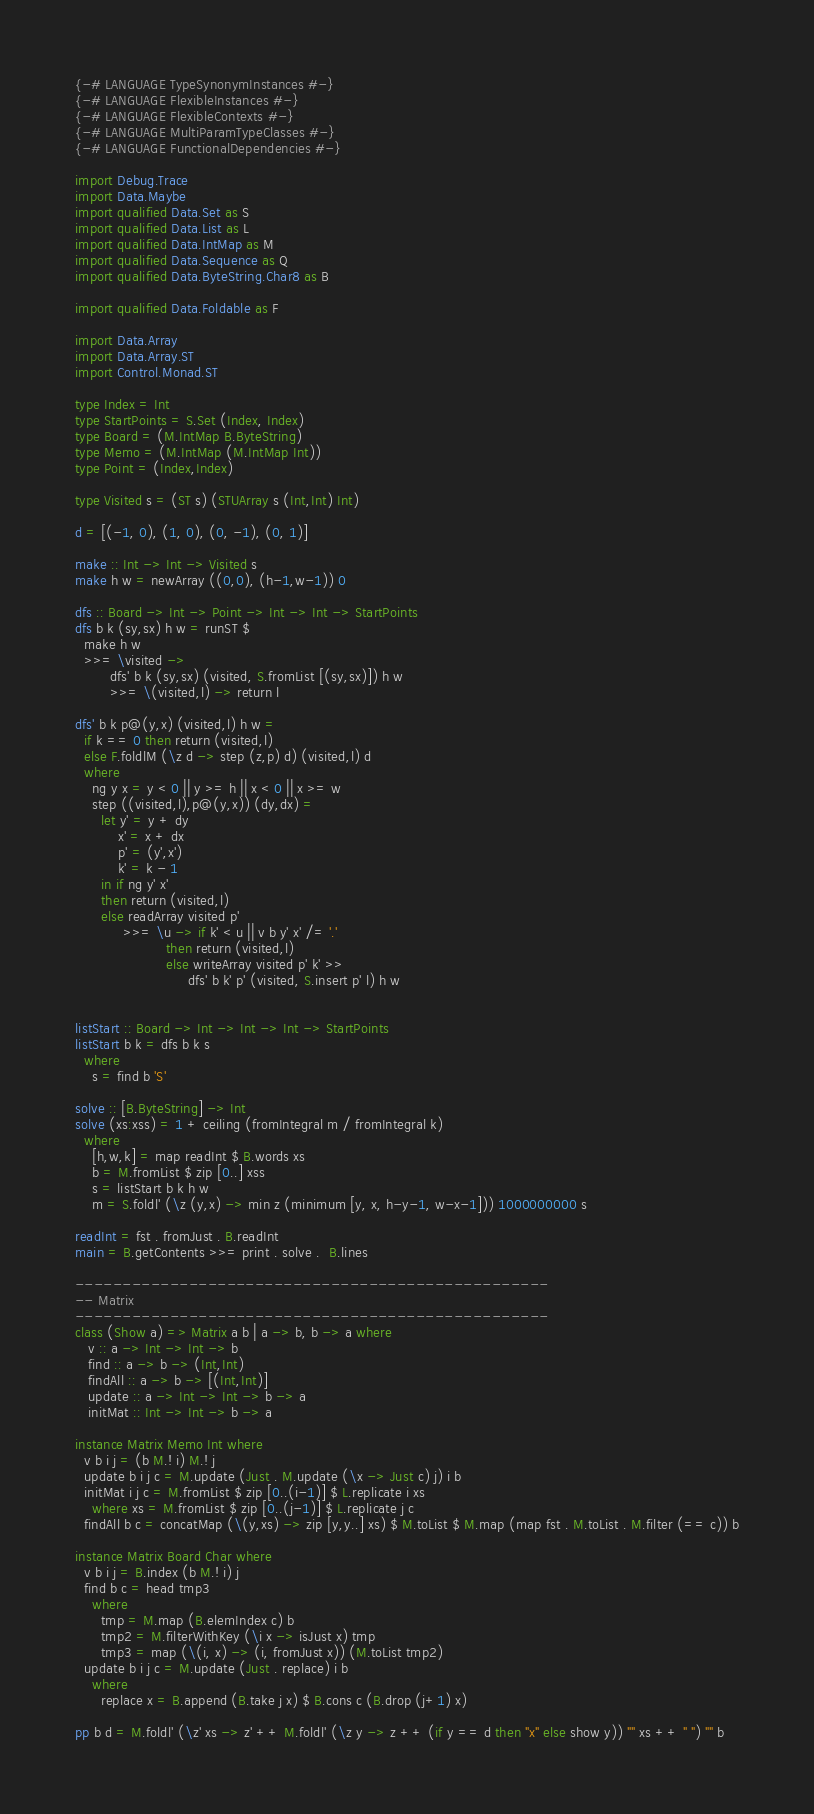Convert code to text. <code><loc_0><loc_0><loc_500><loc_500><_Haskell_>{-# LANGUAGE TypeSynonymInstances #-}
{-# LANGUAGE FlexibleInstances #-}
{-# LANGUAGE FlexibleContexts #-}
{-# LANGUAGE MultiParamTypeClasses #-}
{-# LANGUAGE FunctionalDependencies #-}

import Debug.Trace
import Data.Maybe
import qualified Data.Set as S
import qualified Data.List as L
import qualified Data.IntMap as M
import qualified Data.Sequence as Q
import qualified Data.ByteString.Char8 as B

import qualified Data.Foldable as F

import Data.Array
import Data.Array.ST
import Control.Monad.ST

type Index = Int
type StartPoints = S.Set (Index, Index)
type Board = (M.IntMap B.ByteString)
type Memo = (M.IntMap (M.IntMap Int))
type Point = (Index,Index)

type Visited s = (ST s) (STUArray s (Int,Int) Int)

d = [(-1, 0), (1, 0), (0, -1), (0, 1)]

make :: Int -> Int -> Visited s
make h w = newArray ((0,0), (h-1,w-1)) 0

dfs :: Board -> Int -> Point -> Int -> Int -> StartPoints
dfs b k (sy,sx) h w = runST $
  make h w
  >>= \visited ->
        dfs' b k (sy,sx) (visited, S.fromList [(sy,sx)]) h w
        >>= \(visited,l) -> return l

dfs' b k p@(y,x) (visited,l) h w =
  if k == 0 then return (visited,l)
  else F.foldlM (\z d -> step (z,p) d) (visited,l) d
  where
    ng y x = y < 0 || y >= h || x < 0 || x >= w
    step ((visited,l),p@(y,x)) (dy,dx) =
      let y' = y + dy
          x' = x + dx
          p' = (y',x')
          k' = k - 1
      in if ng y' x'
      then return (visited,l)
      else readArray visited p'
           >>= \u -> if k' < u || v b y' x' /= '.'
                     then return (visited,l)
                     else writeArray visited p' k' >>
                          dfs' b k' p' (visited, S.insert p' l) h w


listStart :: Board -> Int -> Int -> Int -> StartPoints
listStart b k = dfs b k s
  where
    s = find b 'S'

solve :: [B.ByteString] -> Int
solve (xs:xss) = 1 + ceiling (fromIntegral m / fromIntegral k)
  where
    [h,w,k] = map readInt $ B.words xs
    b = M.fromList $ zip [0..] xss
    s = listStart b k h w
    m = S.foldl' (\z (y,x) -> min z (minimum [y, x, h-y-1, w-x-1])) 1000000000 s

readInt = fst . fromJust . B.readInt
main = B.getContents >>= print . solve .  B.lines

--------------------------------------------------
-- Matrix
--------------------------------------------------
class (Show a) => Matrix a b | a -> b, b -> a where
   v :: a -> Int -> Int -> b
   find :: a -> b -> (Int,Int)
   findAll :: a -> b -> [(Int,Int)]
   update :: a -> Int -> Int -> b -> a
   initMat :: Int -> Int -> b -> a

instance Matrix Memo Int where
  v b i j = (b M.! i) M.! j
  update b i j c = M.update (Just . M.update (\x -> Just c) j) i b
  initMat i j c = M.fromList $ zip [0..(i-1)] $ L.replicate i xs
    where xs = M.fromList $ zip [0..(j-1)] $ L.replicate j c
  findAll b c = concatMap (\(y,xs) -> zip [y,y..] xs) $ M.toList $ M.map (map fst . M.toList . M.filter (== c)) b

instance Matrix Board Char where
  v b i j = B.index (b M.! i) j
  find b c = head tmp3
    where
      tmp = M.map (B.elemIndex c) b
      tmp2 = M.filterWithKey (\i x -> isJust x) tmp
      tmp3 = map (\(i, x) -> (i, fromJust x)) (M.toList tmp2)
  update b i j c = M.update (Just . replace) i b
    where
      replace x = B.append (B.take j x) $ B.cons c (B.drop (j+1) x)

pp b d = M.foldl' (\z' xs -> z' ++ M.foldl' (\z y -> z ++ (if y == d then "x" else show y)) "" xs ++ " ") "" b
</code> 